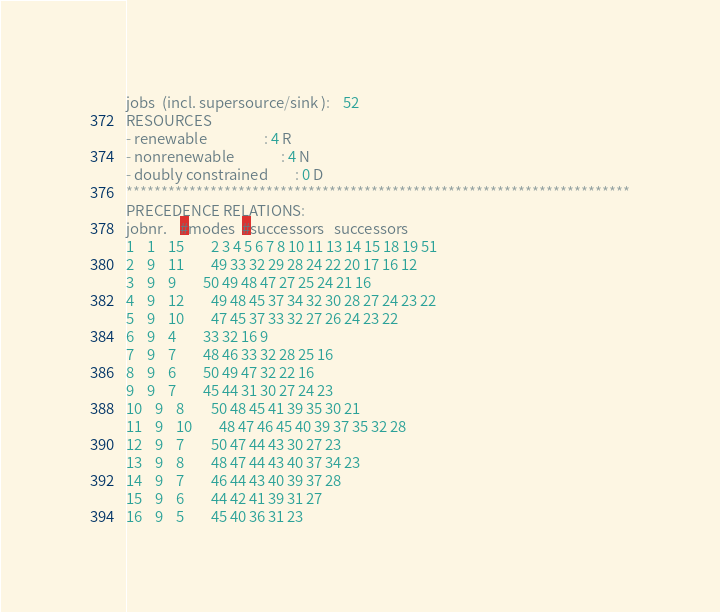Convert code to text. <code><loc_0><loc_0><loc_500><loc_500><_ObjectiveC_>jobs  (incl. supersource/sink ):	52
RESOURCES
- renewable                 : 4 R
- nonrenewable              : 4 N
- doubly constrained        : 0 D
************************************************************************
PRECEDENCE RELATIONS:
jobnr.    #modes  #successors   successors
1	1	15		2 3 4 5 6 7 8 10 11 13 14 15 18 19 51 
2	9	11		49 33 32 29 28 24 22 20 17 16 12 
3	9	9		50 49 48 47 27 25 24 21 16 
4	9	12		49 48 45 37 34 32 30 28 27 24 23 22 
5	9	10		47 45 37 33 32 27 26 24 23 22 
6	9	4		33 32 16 9 
7	9	7		48 46 33 32 28 25 16 
8	9	6		50 49 47 32 22 16 
9	9	7		45 44 31 30 27 24 23 
10	9	8		50 48 45 41 39 35 30 21 
11	9	10		48 47 46 45 40 39 37 35 32 28 
12	9	7		50 47 44 43 30 27 23 
13	9	8		48 47 44 43 40 37 34 23 
14	9	7		46 44 43 40 39 37 28 
15	9	6		44 42 41 39 31 27 
16	9	5		45 40 36 31 23 </code> 